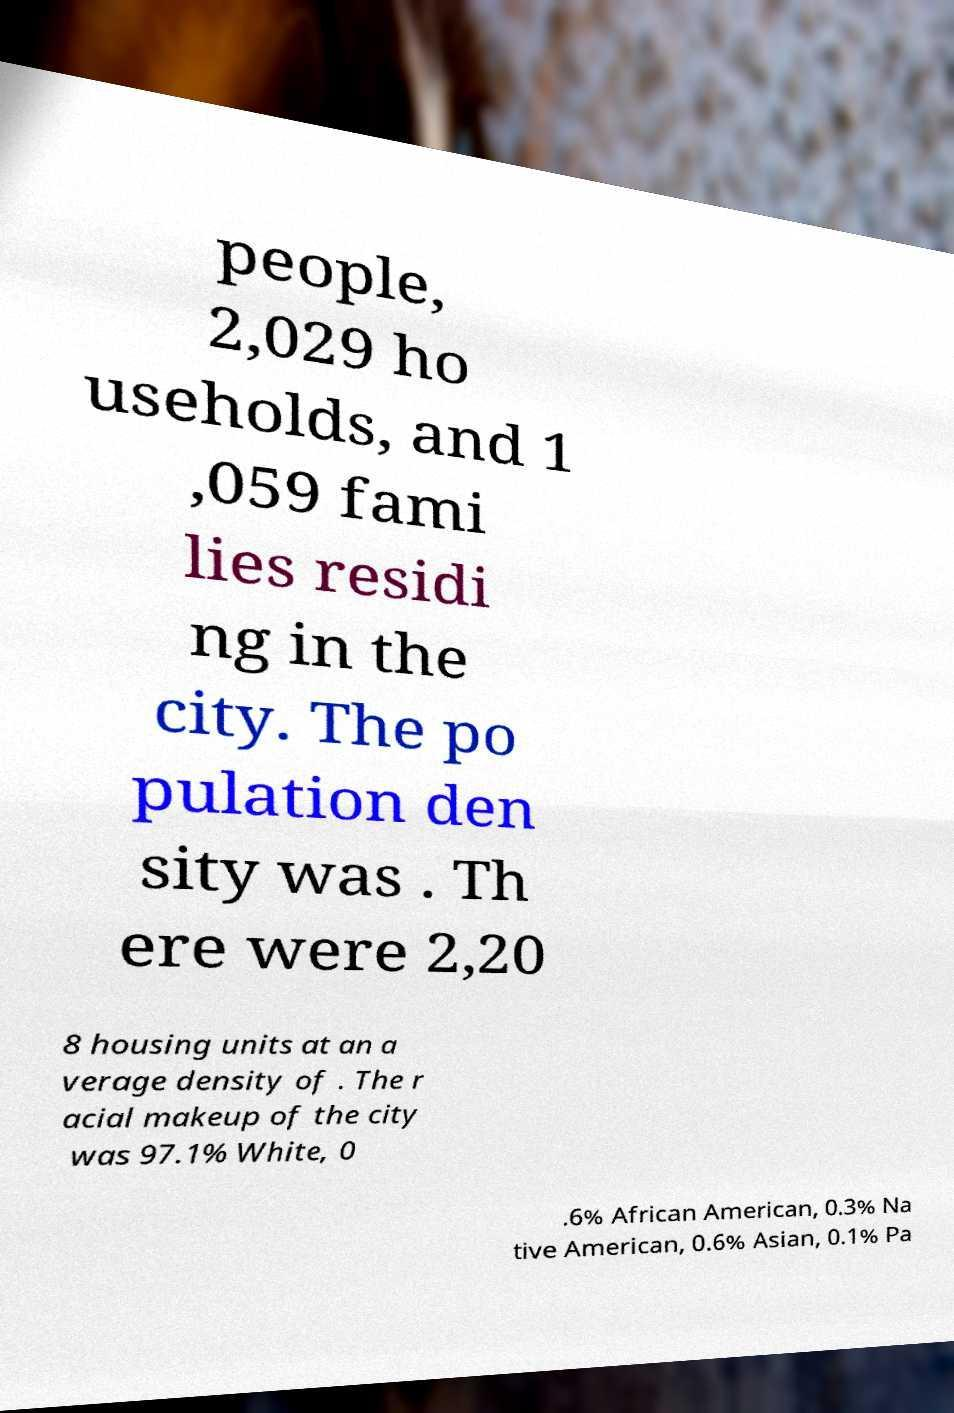Can you read and provide the text displayed in the image?This photo seems to have some interesting text. Can you extract and type it out for me? people, 2,029 ho useholds, and 1 ,059 fami lies residi ng in the city. The po pulation den sity was . Th ere were 2,20 8 housing units at an a verage density of . The r acial makeup of the city was 97.1% White, 0 .6% African American, 0.3% Na tive American, 0.6% Asian, 0.1% Pa 